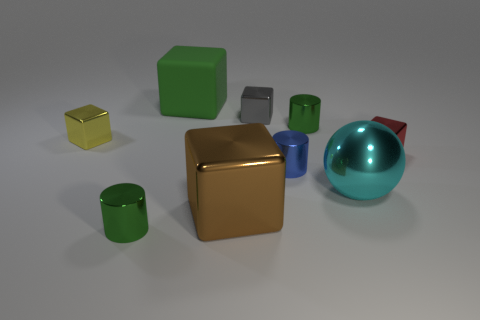What is the relation of the red object to the large gold cube? The red object, which is a pyramid, is positioned to the right of the large gold cube, slightly behind it from this perspective.  Could you estimate how many objects possess rounded edges or surfaces? Based on this view, three objects have rounded surfaces: the large blue sphere, along with the green and blue cylinders. 